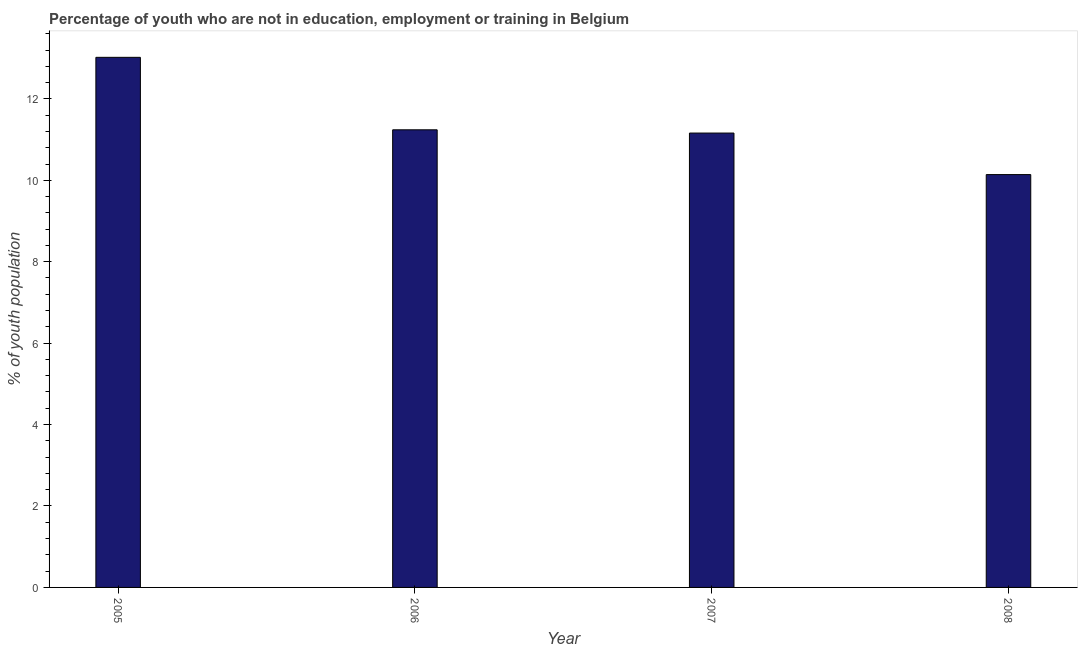What is the title of the graph?
Offer a terse response. Percentage of youth who are not in education, employment or training in Belgium. What is the label or title of the Y-axis?
Offer a very short reply. % of youth population. What is the unemployed youth population in 2007?
Provide a succinct answer. 11.16. Across all years, what is the maximum unemployed youth population?
Your response must be concise. 13.02. Across all years, what is the minimum unemployed youth population?
Provide a short and direct response. 10.14. In which year was the unemployed youth population maximum?
Ensure brevity in your answer.  2005. In which year was the unemployed youth population minimum?
Your answer should be very brief. 2008. What is the sum of the unemployed youth population?
Provide a short and direct response. 45.56. What is the difference between the unemployed youth population in 2005 and 2008?
Your answer should be very brief. 2.88. What is the average unemployed youth population per year?
Your answer should be very brief. 11.39. What is the median unemployed youth population?
Offer a terse response. 11.2. What is the ratio of the unemployed youth population in 2006 to that in 2008?
Provide a succinct answer. 1.11. Is the difference between the unemployed youth population in 2007 and 2008 greater than the difference between any two years?
Offer a very short reply. No. What is the difference between the highest and the second highest unemployed youth population?
Offer a terse response. 1.78. Is the sum of the unemployed youth population in 2006 and 2008 greater than the maximum unemployed youth population across all years?
Keep it short and to the point. Yes. What is the difference between the highest and the lowest unemployed youth population?
Provide a short and direct response. 2.88. In how many years, is the unemployed youth population greater than the average unemployed youth population taken over all years?
Make the answer very short. 1. Are all the bars in the graph horizontal?
Ensure brevity in your answer.  No. What is the difference between two consecutive major ticks on the Y-axis?
Make the answer very short. 2. What is the % of youth population in 2005?
Ensure brevity in your answer.  13.02. What is the % of youth population of 2006?
Your answer should be very brief. 11.24. What is the % of youth population in 2007?
Keep it short and to the point. 11.16. What is the % of youth population of 2008?
Offer a terse response. 10.14. What is the difference between the % of youth population in 2005 and 2006?
Ensure brevity in your answer.  1.78. What is the difference between the % of youth population in 2005 and 2007?
Your answer should be very brief. 1.86. What is the difference between the % of youth population in 2005 and 2008?
Keep it short and to the point. 2.88. What is the difference between the % of youth population in 2006 and 2007?
Keep it short and to the point. 0.08. What is the ratio of the % of youth population in 2005 to that in 2006?
Keep it short and to the point. 1.16. What is the ratio of the % of youth population in 2005 to that in 2007?
Ensure brevity in your answer.  1.17. What is the ratio of the % of youth population in 2005 to that in 2008?
Keep it short and to the point. 1.28. What is the ratio of the % of youth population in 2006 to that in 2007?
Your answer should be very brief. 1.01. What is the ratio of the % of youth population in 2006 to that in 2008?
Provide a short and direct response. 1.11. What is the ratio of the % of youth population in 2007 to that in 2008?
Your response must be concise. 1.1. 